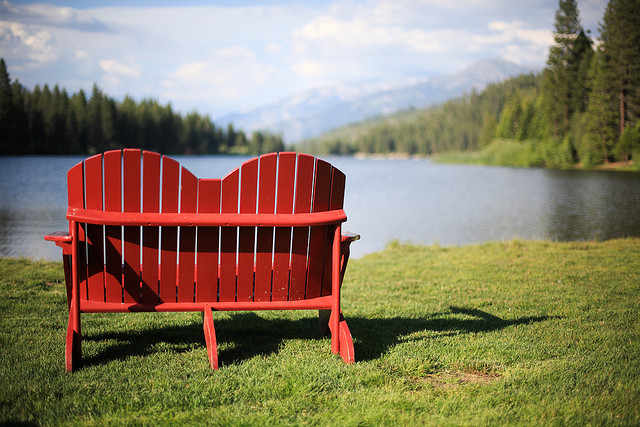Imagine if this location were a scene in a fantasy novel. Describe a fantastical event that could happen here. As the sun began to set, casting a golden glow over the serene lake, something extraordinary happened. The waters shimmered with a mystical light, and from their depths emerged the majestic Queen of the Lake, a mythical creature of ethereal beauty. Draped in garments made of shimmering fish scales and crowned with pearls, she gracefully walked towards the red bench, her footsteps leaving a trail of luminescent flowers. Legend has it that once every century, the Queen rises to grant a single wish to those pure of heart. The air was filled with a magical hum as she approached, and all the creatures of the forest gathered in silent reverence. It was a moment of wonder, where the boundaries between the natural and the magical worlds blurred, leaving an indelible mark on all who were fortunate enough to witness it. 